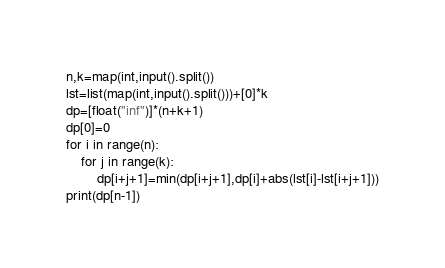<code> <loc_0><loc_0><loc_500><loc_500><_Python_>n,k=map(int,input().split())
lst=list(map(int,input().split()))+[0]*k
dp=[float("inf")]*(n+k+1)
dp[0]=0
for i in range(n):
    for j in range(k):
        dp[i+j+1]=min(dp[i+j+1],dp[i]+abs(lst[i]-lst[i+j+1]))
print(dp[n-1])</code> 